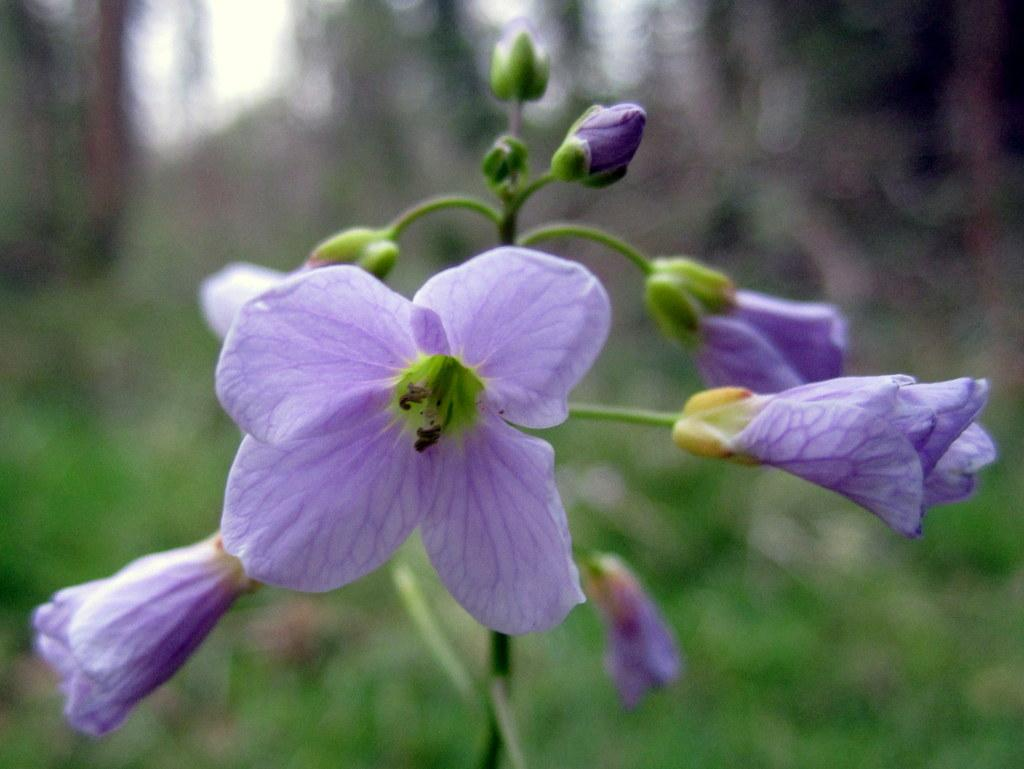What is the main subject of the image? There is a flower in the image. Can you describe the background of the image? The background of the image is blurry. What type of mailbox is present in the image? There is no mailbox present in the image; it only features a flower and a blurry background. How low is the flower in the image? The height of the flower in the image cannot be determined from the provided facts, as there is no reference point for comparison. 